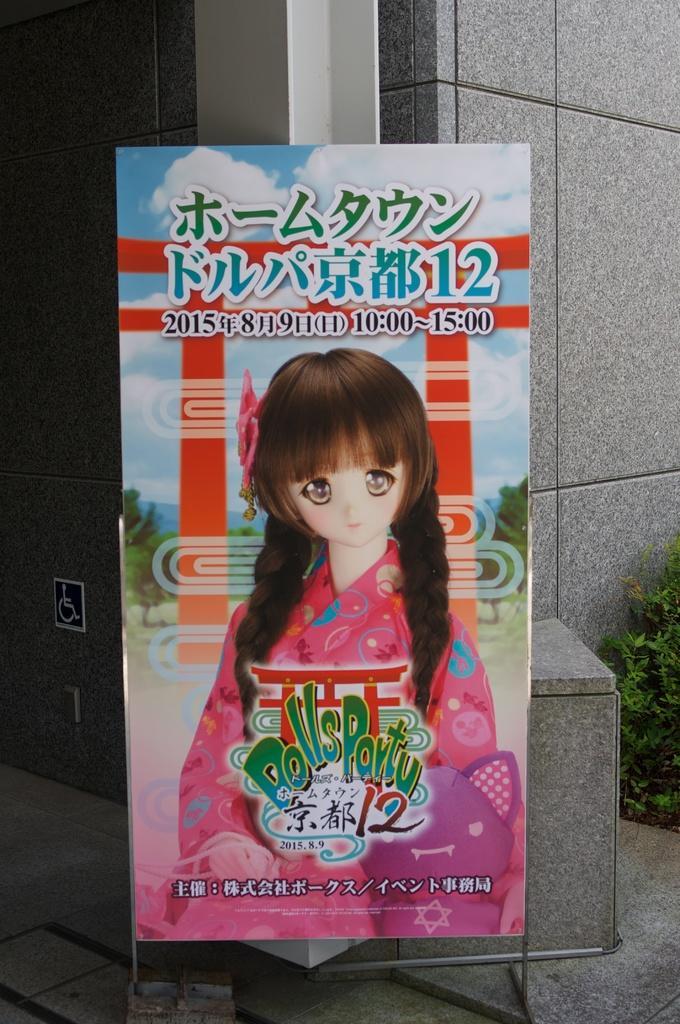In one or two sentences, can you explain what this image depicts? In this picture we can see a board, there is a depiction of a doll and some text on the board, in the background there is a wall, we can see a plant on the right side. 